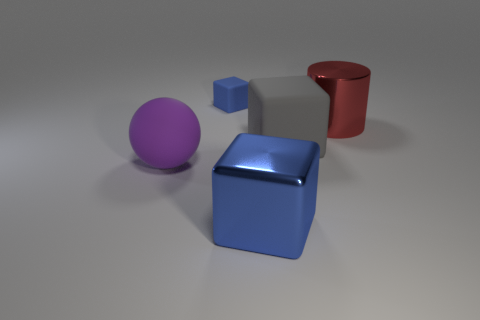There is a thing that is in front of the large gray object and to the right of the purple ball; what is its color?
Provide a succinct answer. Blue. Are there more small blue rubber blocks in front of the red object than large purple things that are to the right of the gray object?
Provide a short and direct response. No. There is a thing that is on the right side of the large gray rubber block; what is its color?
Give a very brief answer. Red. Is the shape of the metallic thing that is behind the large purple matte thing the same as the matte thing that is in front of the gray object?
Provide a succinct answer. No. Are there any other gray metal blocks of the same size as the metallic block?
Offer a terse response. No. What is the blue object that is behind the big gray rubber thing made of?
Give a very brief answer. Rubber. Are the blue cube that is in front of the tiny blue matte block and the big gray object made of the same material?
Provide a succinct answer. No. Are any small purple cylinders visible?
Provide a succinct answer. No. There is a small object that is the same material as the purple sphere; what is its color?
Provide a succinct answer. Blue. What is the color of the shiny object that is on the right side of the rubber block to the right of the metallic object on the left side of the red cylinder?
Your answer should be very brief. Red. 